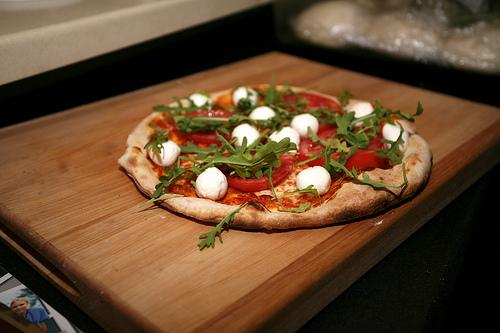List three different toppings you can find on the pizza in the image. Mozzarella cheese, fresh arugula, and sliced red tomatoes Please provide a short caption summarizing the main characteristics of the pizza in the image. Vegetarian pizza with fresh toppings, served on a wooden cutting board What type of surface is the pizza placed on? A wooden cutting board with a carved-out handle What emotion or theme does the image evoke? A sense of freshness and natural ingredients in a rustic, homemade setting. Describe the visual appearance of the pizza's crust. The pizza crust has a brown and beige color with a slightly burnt portion In the image, there is an unrelated object to the pizza scene. Describe what it is and its location. There is a photograph of a young woman in a blue shirt located in the bottom-left corner of the image. What is one unique detail about the crust in this image? There is a burnt portion of the pizza crust Identify the type of pizza by mentioning its toppings. A fresh vegetarian pizza with cheese, arugula, and tomatoes Estimate the number of arugula leaves visible on top of the pizza. Approximately 16-20 arugula leaves are visible on the pizza What type of cheese is featured prominently in the image? Round white mozzarella cheese balls Are there slices of pepperoni on the veggie pizza? The instruction is misleading because the pizza is described as a vegetarian pizza with cheese, tomatoes, and arugula, not pepperoni. Are the fresh arugula greens on a pizza shaped like hearts? The instruction is misleading because it doesn't provide any information about the shape of the arugula leaves. Arugula typically has a lobed leaf shape, not heart-shaped. List all the captions that mention pizza. Vegetarian pizza with fresh toppings, served on a wooden cutting board Is the cheese topping on a pizza made of blue cheese? The instruction is misleading because the cheese is described as white mozzarella, not blue cheese. Identify any text or symbols in the image. No text or symbols found. Is the cutting board made of plastic? The instruction is misleading because the cutting board is described as a solid wood cutting board, not plastic. Is there any anomaly in the representation of objects in the image? No Describe the interaction between pizza toppings and the crust. The pizza crust is topped with cheese, tomatoes, tomato sauce, and arugula. Which caption refers to a circular object? a circle cooked pizza Identify the areas of the image where arugula toppings are. The arugula toppings are scattered evenly across the surface of the pizza. Is the image of high-quality? Yes Does the photograph of a young woman show her wearing an orange dress? The instruction is misleading because the photograph of a woman is described as wearing a blue shirt, not an orange dress. Is the leafy green piece of arugula purple in color? The instruction is misleading because arugula is a green leafy vegetable, not purple. What color is the young woman's shirt? Blue Which caption contains a wooden board? Vegetarian pizza with fresh toppings, served on a wooden cutting board What is the sentiment portrayed in this image? Positive 